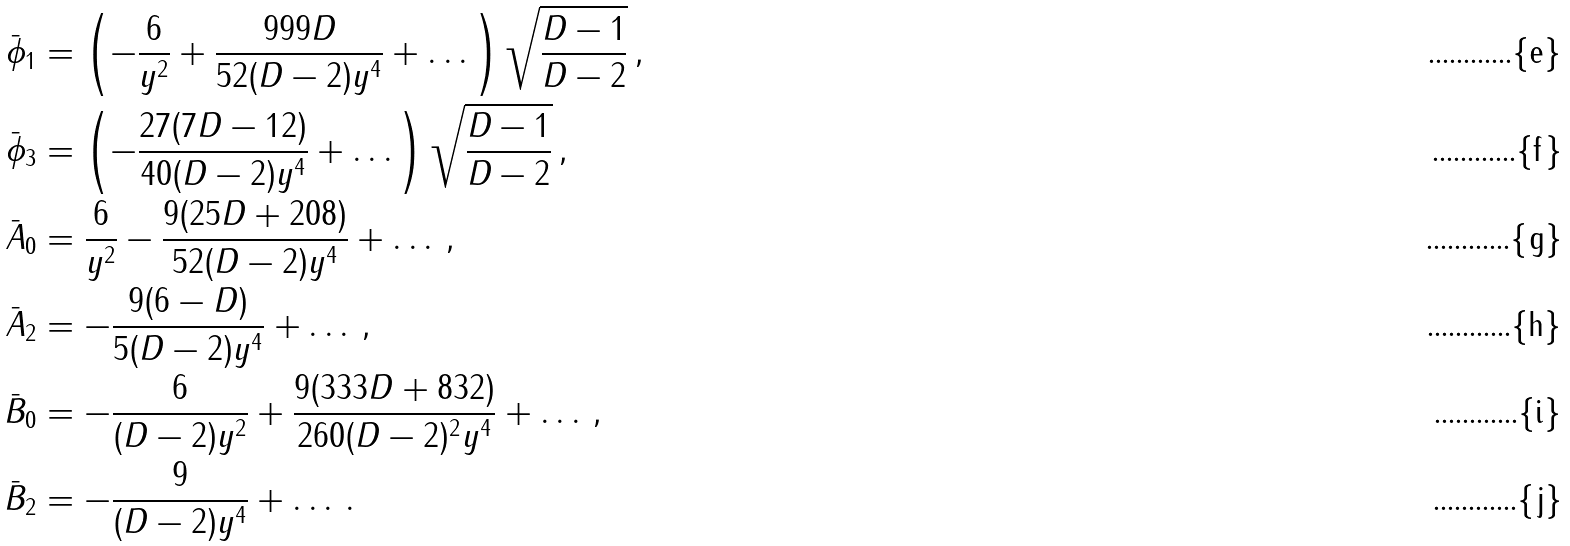<formula> <loc_0><loc_0><loc_500><loc_500>\bar { \phi } _ { 1 } & = \left ( - \frac { 6 } { y ^ { 2 } } + \frac { 9 9 9 D } { 5 2 ( D - 2 ) y ^ { 4 } } + \dots \right ) \sqrt { \frac { D - 1 } { D - 2 } } \, , \\ \bar { \phi } _ { 3 } & = \left ( - \frac { 2 7 ( 7 D - 1 2 ) } { 4 0 ( D - 2 ) y ^ { 4 } } + \dots \right ) \sqrt { \frac { D - 1 } { D - 2 } } \, , \\ \bar { A } _ { 0 } & = \frac { 6 } { y ^ { 2 } } - \frac { 9 ( 2 5 D + 2 0 8 ) } { 5 2 ( D - 2 ) y ^ { 4 } } + \dots \, , \\ \bar { A } _ { 2 } & = - \frac { 9 ( 6 - D ) } { 5 ( D - 2 ) y ^ { 4 } } + \dots \, , \\ \bar { B } _ { 0 } & = - \frac { 6 } { ( D - 2 ) y ^ { 2 } } + \frac { 9 ( 3 3 3 D + 8 3 2 ) } { 2 6 0 ( D - 2 ) ^ { 2 } y ^ { 4 } } + \dots \, , \\ \bar { B } _ { 2 } & = - \frac { 9 } { ( D - 2 ) y ^ { 4 } } + \dots \, .</formula> 